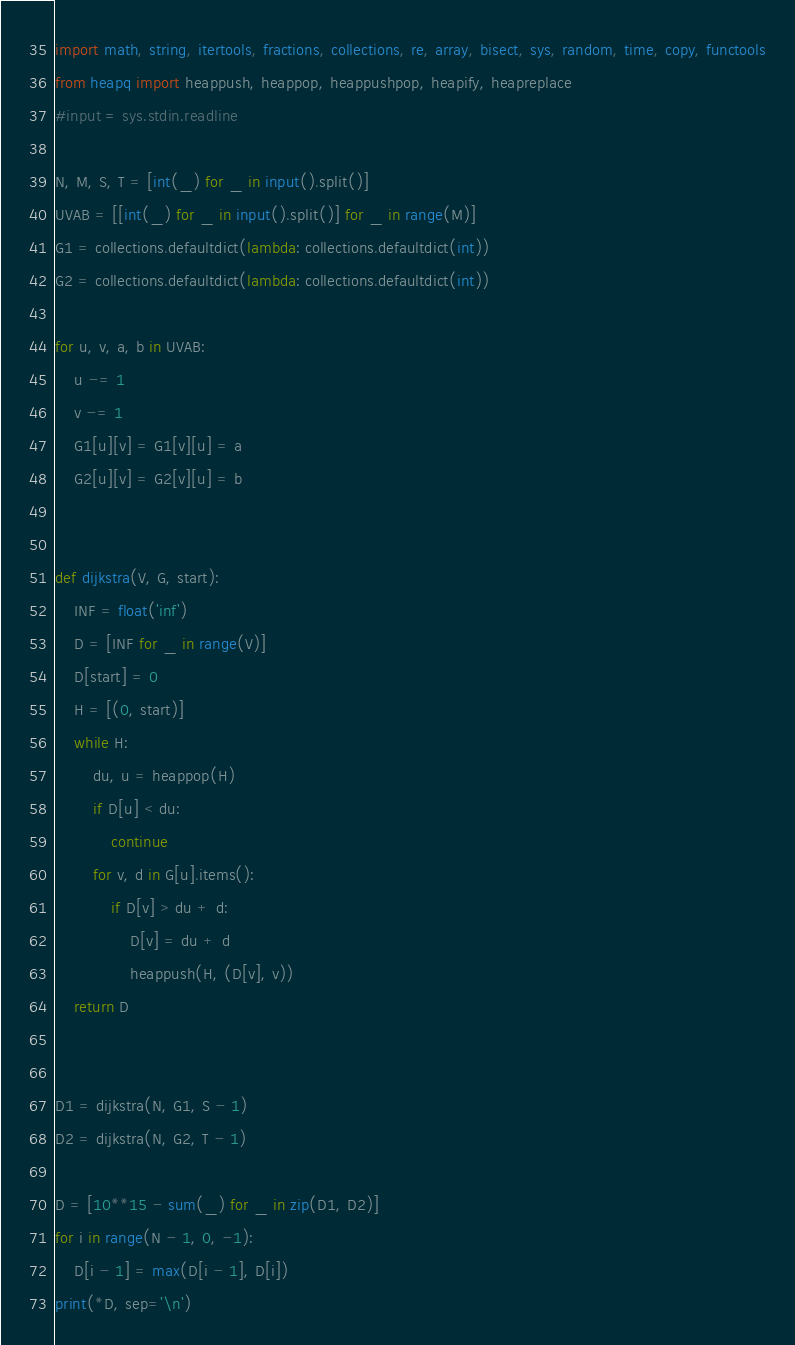Convert code to text. <code><loc_0><loc_0><loc_500><loc_500><_Python_>import math, string, itertools, fractions, collections, re, array, bisect, sys, random, time, copy, functools
from heapq import heappush, heappop, heappushpop, heapify, heapreplace
#input = sys.stdin.readline

N, M, S, T = [int(_) for _ in input().split()]
UVAB = [[int(_) for _ in input().split()] for _ in range(M)]
G1 = collections.defaultdict(lambda: collections.defaultdict(int))
G2 = collections.defaultdict(lambda: collections.defaultdict(int))

for u, v, a, b in UVAB:
    u -= 1
    v -= 1
    G1[u][v] = G1[v][u] = a
    G2[u][v] = G2[v][u] = b


def dijkstra(V, G, start):
    INF = float('inf')
    D = [INF for _ in range(V)]
    D[start] = 0
    H = [(0, start)]
    while H:
        du, u = heappop(H)
        if D[u] < du:
            continue
        for v, d in G[u].items():
            if D[v] > du + d:
                D[v] = du + d
                heappush(H, (D[v], v))
    return D


D1 = dijkstra(N, G1, S - 1)
D2 = dijkstra(N, G2, T - 1)

D = [10**15 - sum(_) for _ in zip(D1, D2)]
for i in range(N - 1, 0, -1):
    D[i - 1] = max(D[i - 1], D[i])
print(*D, sep='\n')
</code> 